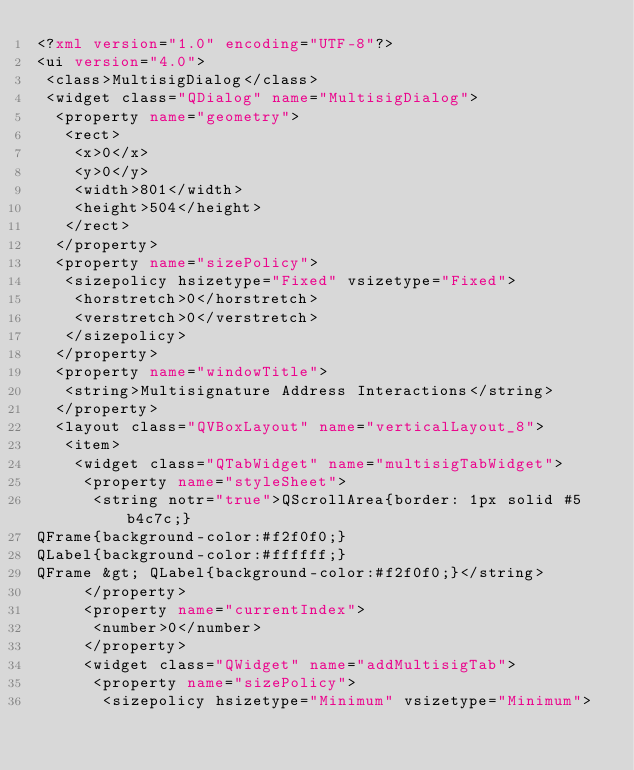Convert code to text. <code><loc_0><loc_0><loc_500><loc_500><_XML_><?xml version="1.0" encoding="UTF-8"?>
<ui version="4.0">
 <class>MultisigDialog</class>
 <widget class="QDialog" name="MultisigDialog">
  <property name="geometry">
   <rect>
    <x>0</x>
    <y>0</y>
    <width>801</width>
    <height>504</height>
   </rect>
  </property>
  <property name="sizePolicy">
   <sizepolicy hsizetype="Fixed" vsizetype="Fixed">
    <horstretch>0</horstretch>
    <verstretch>0</verstretch>
   </sizepolicy>
  </property>
  <property name="windowTitle">
   <string>Multisignature Address Interactions</string>
  </property>
  <layout class="QVBoxLayout" name="verticalLayout_8">
   <item>
    <widget class="QTabWidget" name="multisigTabWidget">
     <property name="styleSheet">
      <string notr="true">QScrollArea{border: 1px solid #5b4c7c;}
QFrame{background-color:#f2f0f0;}
QLabel{background-color:#ffffff;}
QFrame &gt; QLabel{background-color:#f2f0f0;}</string>
     </property>
     <property name="currentIndex">
      <number>0</number>
     </property>
     <widget class="QWidget" name="addMultisigTab">
      <property name="sizePolicy">
       <sizepolicy hsizetype="Minimum" vsizetype="Minimum"></code> 